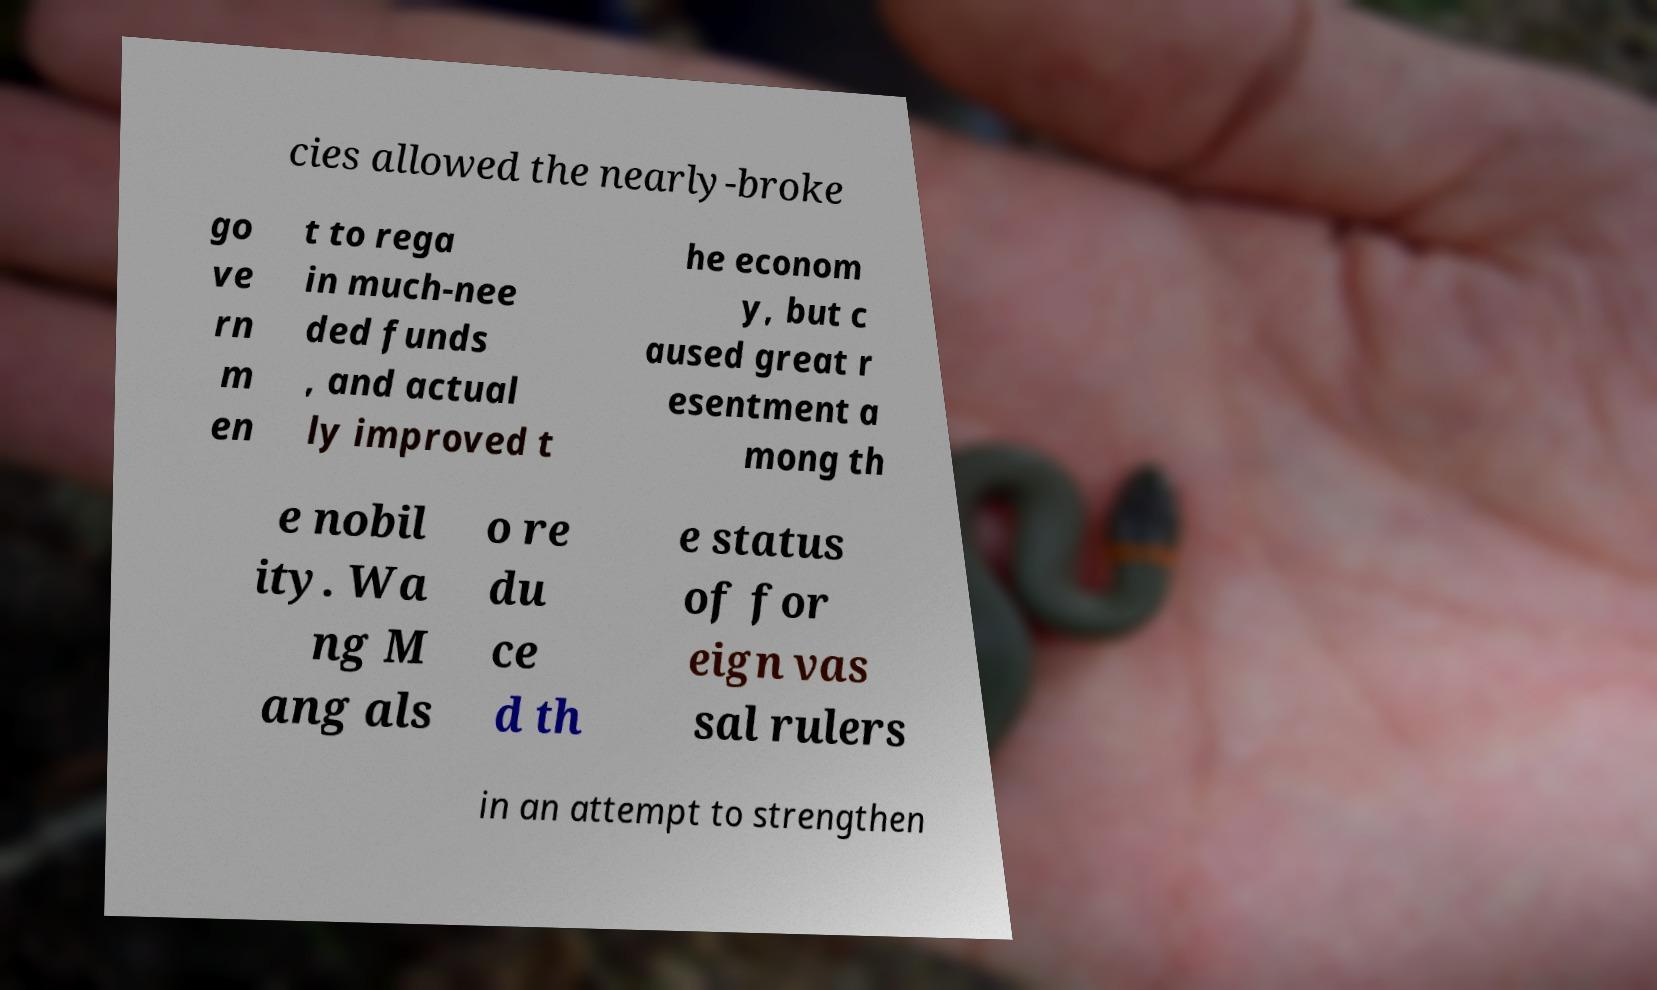For documentation purposes, I need the text within this image transcribed. Could you provide that? cies allowed the nearly-broke go ve rn m en t to rega in much-nee ded funds , and actual ly improved t he econom y, but c aused great r esentment a mong th e nobil ity. Wa ng M ang als o re du ce d th e status of for eign vas sal rulers in an attempt to strengthen 